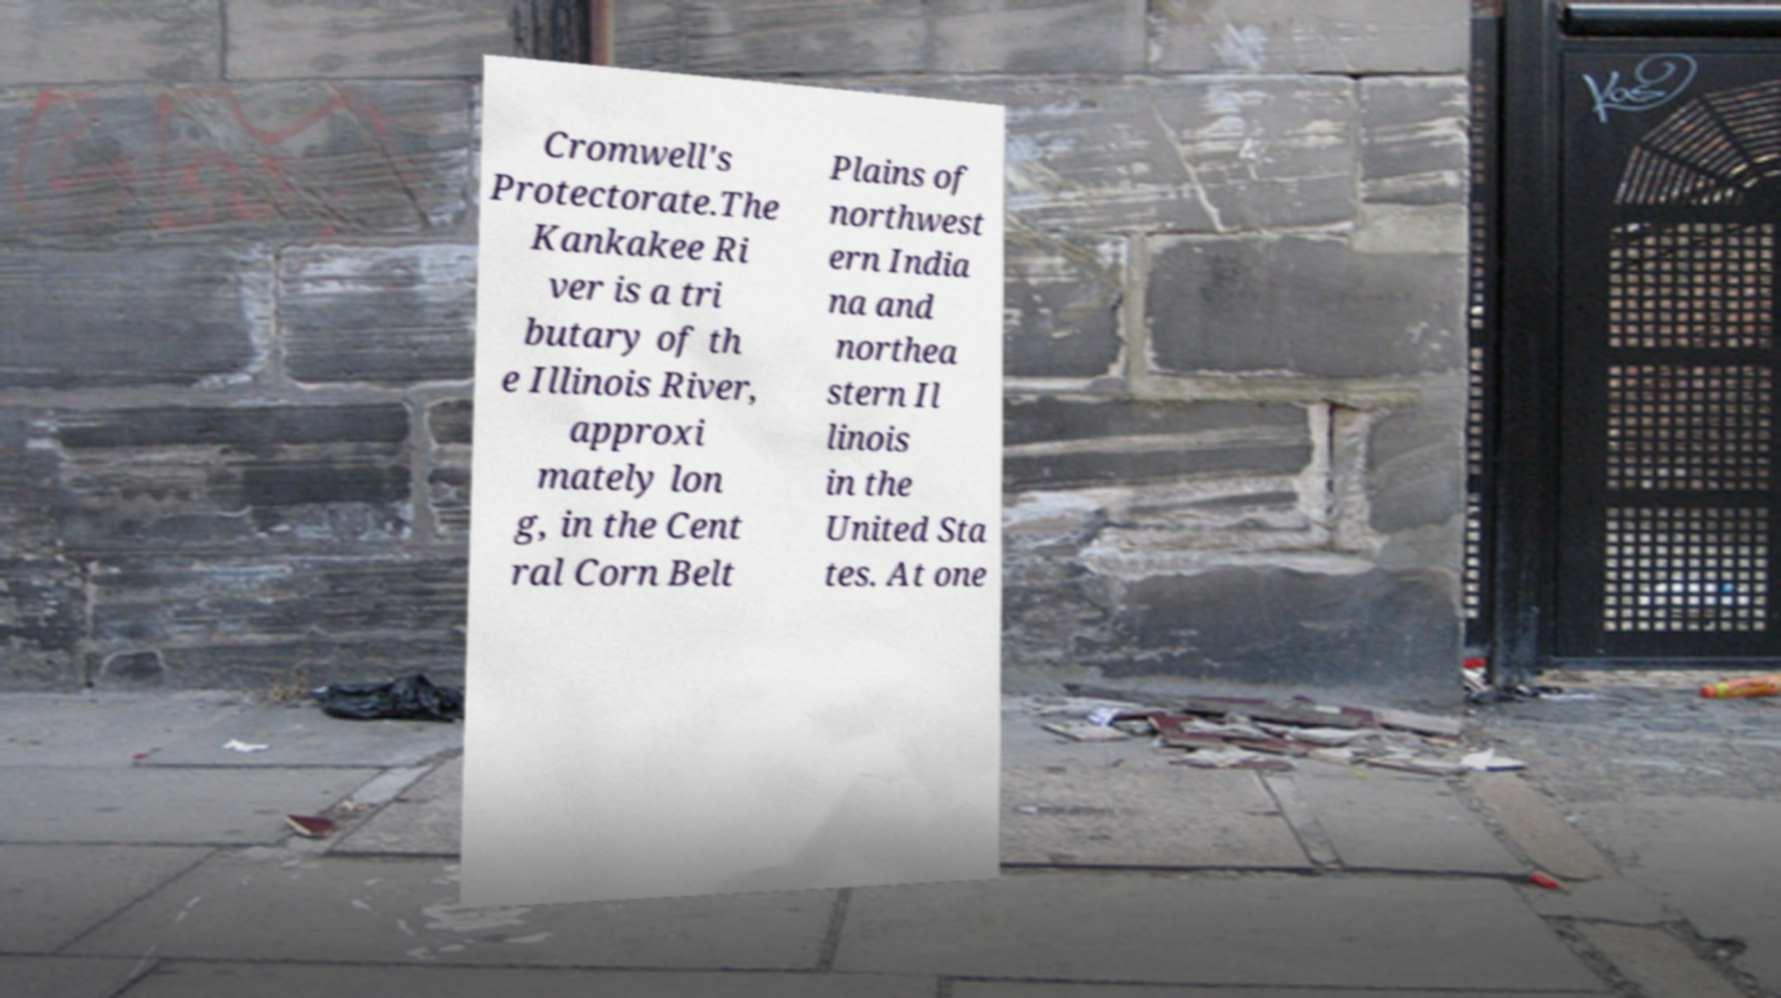Please read and relay the text visible in this image. What does it say? Cromwell's Protectorate.The Kankakee Ri ver is a tri butary of th e Illinois River, approxi mately lon g, in the Cent ral Corn Belt Plains of northwest ern India na and northea stern Il linois in the United Sta tes. At one 